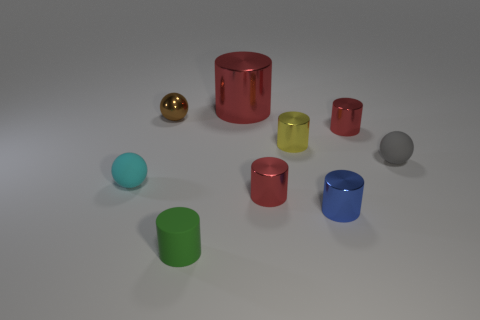How big is the red cylinder that is both behind the gray rubber ball and to the left of the small yellow metal cylinder?
Offer a terse response. Large. Does the large metal cylinder have the same color as the small metal thing that is on the right side of the blue metal thing?
Make the answer very short. Yes. Is there another small rubber object of the same shape as the small blue object?
Your answer should be compact. Yes. What number of objects are either tiny cyan spheres or tiny objects left of the green rubber cylinder?
Provide a short and direct response. 2. What number of other things are there of the same material as the gray object
Ensure brevity in your answer.  2. How many objects are either small gray matte balls or red metallic things?
Give a very brief answer. 4. Is the number of small cylinders that are behind the blue shiny cylinder greater than the number of objects that are in front of the brown sphere?
Give a very brief answer. No. There is a tiny cylinder right of the blue metallic object; does it have the same color as the shiny object that is behind the small brown metallic sphere?
Ensure brevity in your answer.  Yes. How big is the red metallic thing left of the tiny red object that is on the left side of the tiny red metallic cylinder that is behind the tiny cyan rubber sphere?
Provide a short and direct response. Large. What color is the other rubber object that is the same shape as the blue object?
Your response must be concise. Green. 